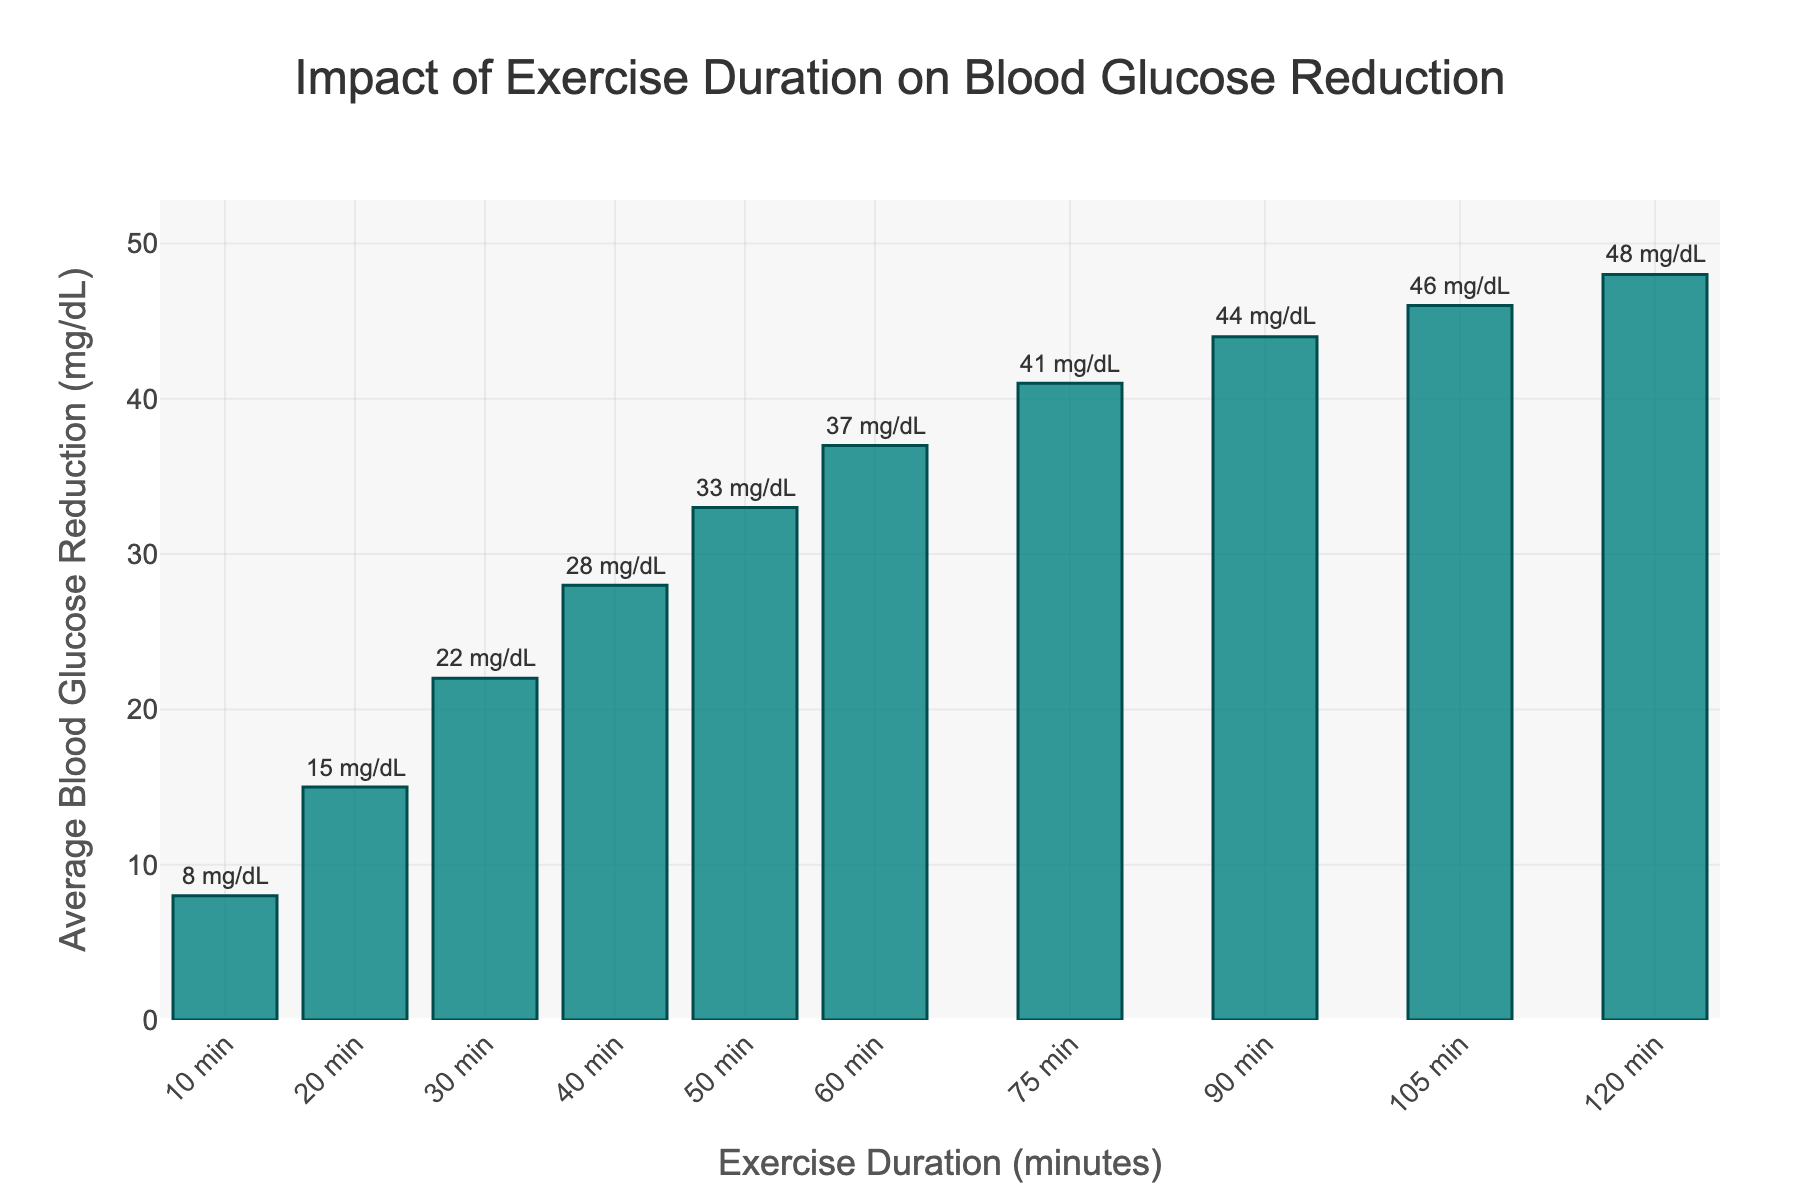What is the average blood glucose reduction for an exercise duration of 60 minutes? Look at the bar corresponding to 60 minutes on the x-axis and check the y-axis value. The value indicated is 37 mg/dL.
Answer: 37 mg/dL Which exercise duration results in the largest blood glucose reduction? Check the height of all the bars and identify the one that is the highest. The bar for 120 minutes has the maximum height corresponding to 48 mg/dL reduction.
Answer: 120 minutes By how much does the blood glucose reduction increase when moving from 30 minutes to 75 minutes of exercise? Find the y-axis values for both durations (30 minutes corresponds to 22 mg/dL and 75 minutes corresponds to 41 mg/dL). Subtract the smaller value from the larger one: 41 mg/dL - 22 mg/dL.
Answer: 19 mg/dL What's the combined blood glucose reduction for exercise durations of 10, 30, and 50 minutes? Add the y-axis values for 10 minutes (8 mg/dL), 30 minutes (22 mg/dL), and 50 minutes (33 mg/dL): 8 + 22 + 33.
Answer: 63 mg/dL How does the blood glucose reduction for 90 minutes compare to that for 40 minutes? Check the y-axis values for both durations (90 minutes is 44 mg/dL and 40 minutes is 28 mg/dL). Subtract the smaller value from the larger one to find the difference: 44 mg/dL - 28 mg/dL.
Answer: 16 mg/dL What is the median blood glucose reduction across all exercise durations shown? List out the y-axis values in ascending order: 8, 15, 22, 28, 33, 37, 41, 44, 46, 48. The median is the average of the two middle values (33 and 37): (33 + 37) / 2.
Answer: 35 mg/dL Which two consecutive exercise durations have the smallest difference in blood glucose reduction? Calculate differences between consecutive y-axis values: (15-8)=7, (22-15)=7, (28-22)=6, (33-28)=5, (37-33)=4, (41-37)=4, (44-41)=3, (46-44)=2, (48-46)=2. The smallest difference is between 105 and 120 minutes (48-46).
Answer: 105 and 120 minutes What is the visual color of the bars in the chart? The bars are visually colored in shades of teal.
Answer: Teal 